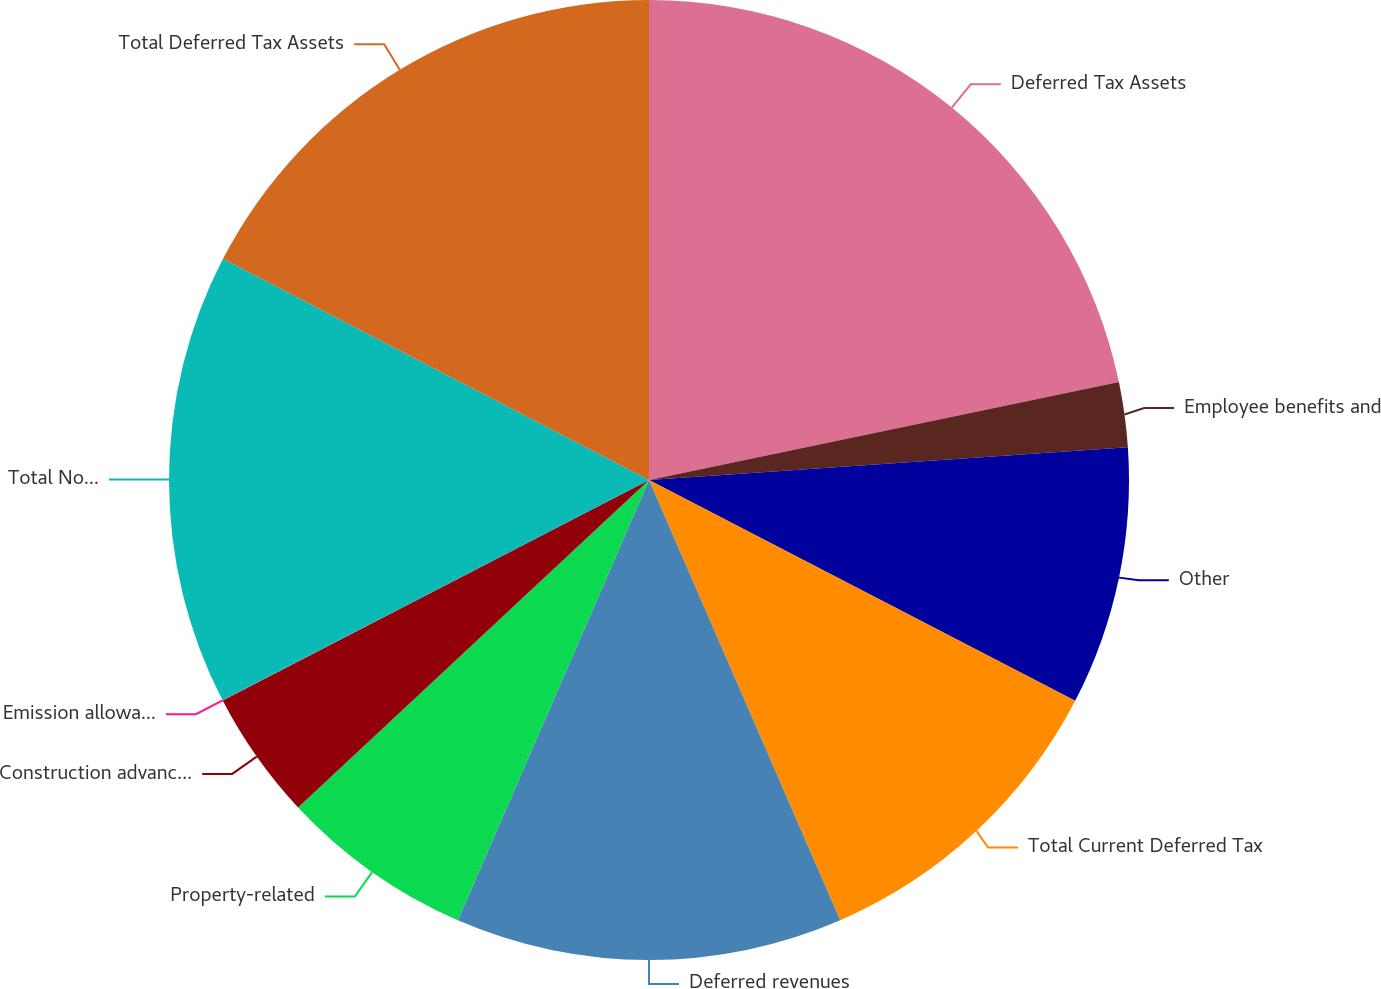Convert chart. <chart><loc_0><loc_0><loc_500><loc_500><pie_chart><fcel>Deferred Tax Assets<fcel>Employee benefits and<fcel>Other<fcel>Total Current Deferred Tax<fcel>Deferred revenues<fcel>Property-related<fcel>Construction advances<fcel>Emission allowances<fcel>Total Non-Current Deferred Tax<fcel>Total Deferred Tax Assets<nl><fcel>21.73%<fcel>2.18%<fcel>8.7%<fcel>10.87%<fcel>13.04%<fcel>6.53%<fcel>4.35%<fcel>0.01%<fcel>15.21%<fcel>17.38%<nl></chart> 